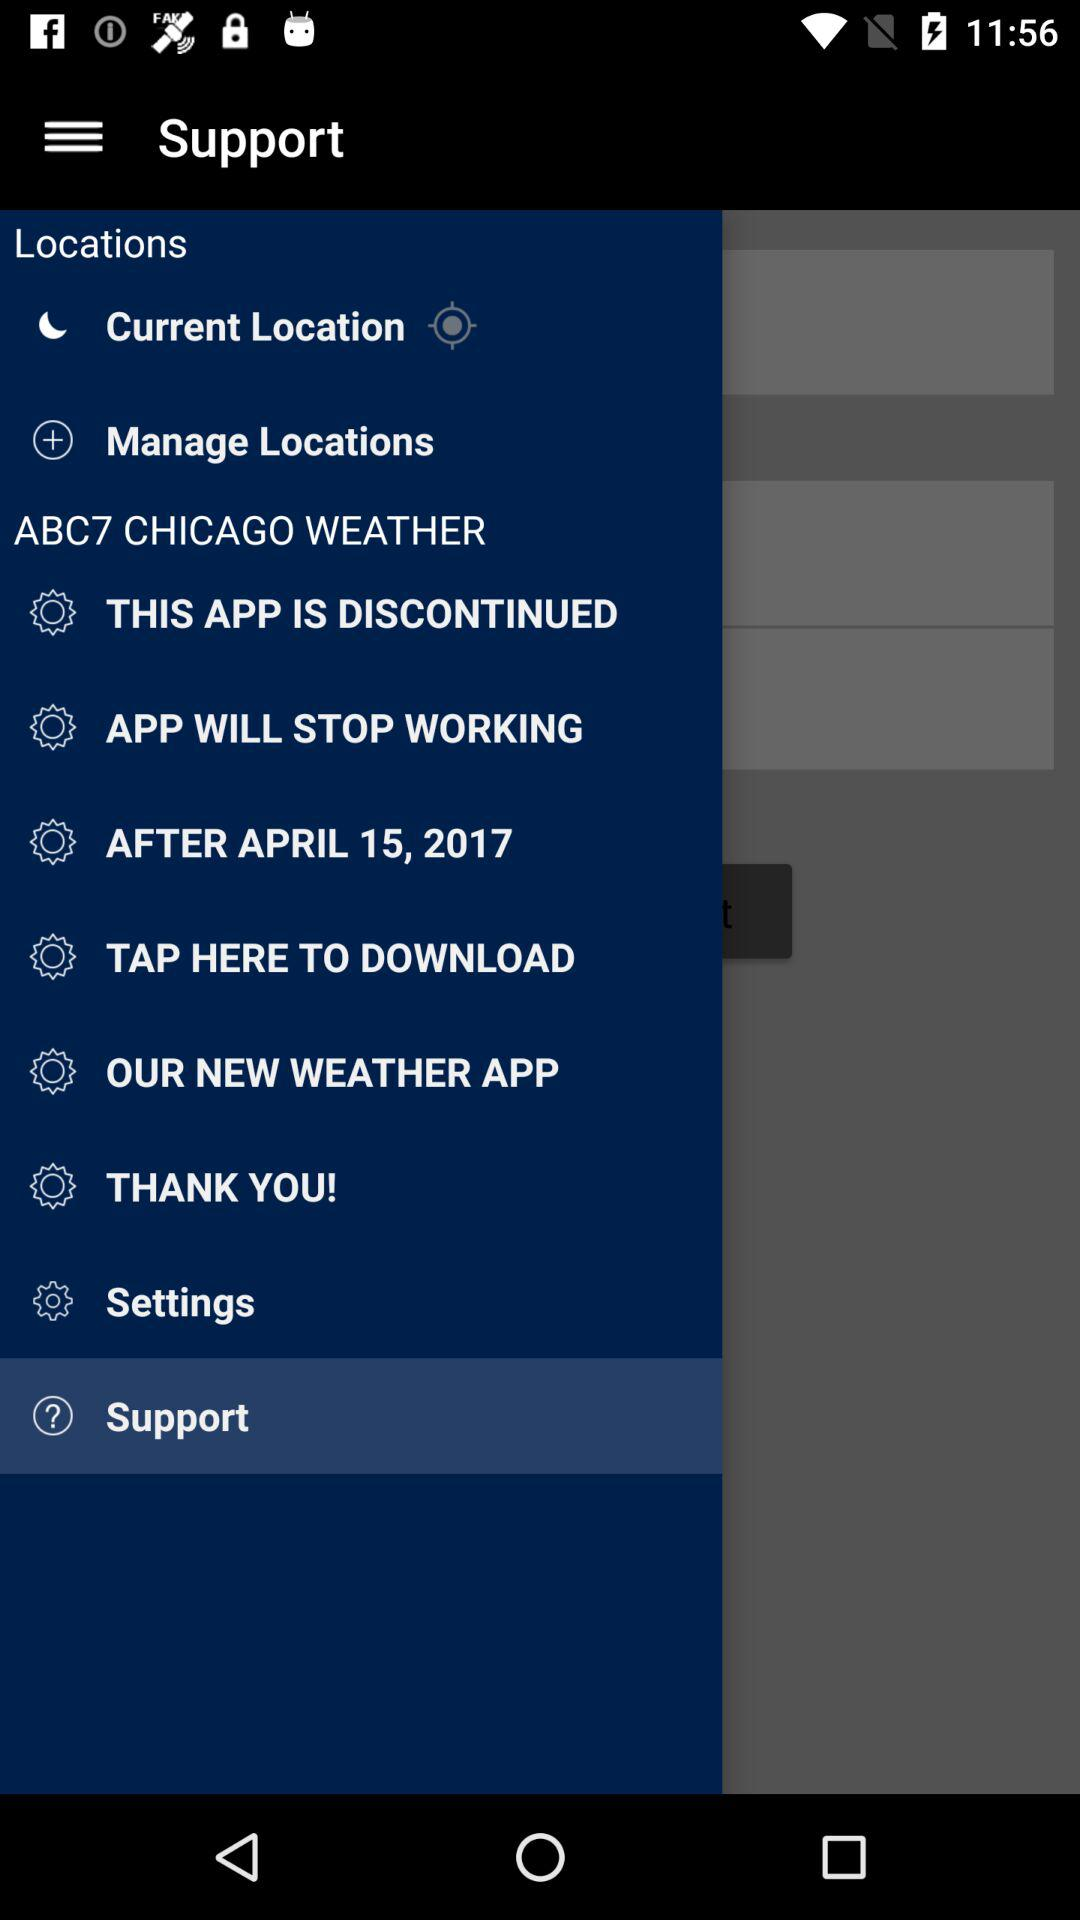What is the selected library? The selected library is "Support". 